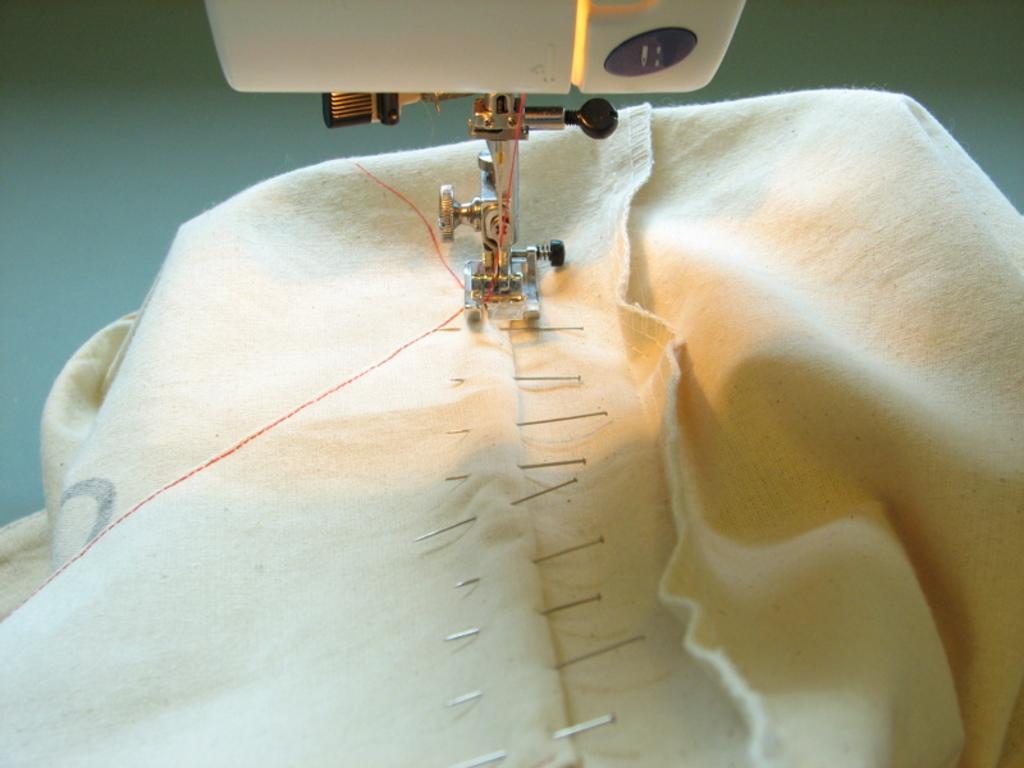Please provide a concise description of this image. In the picture there is a cloth, on the cloth there are needles present, there is a stitching machine present. 